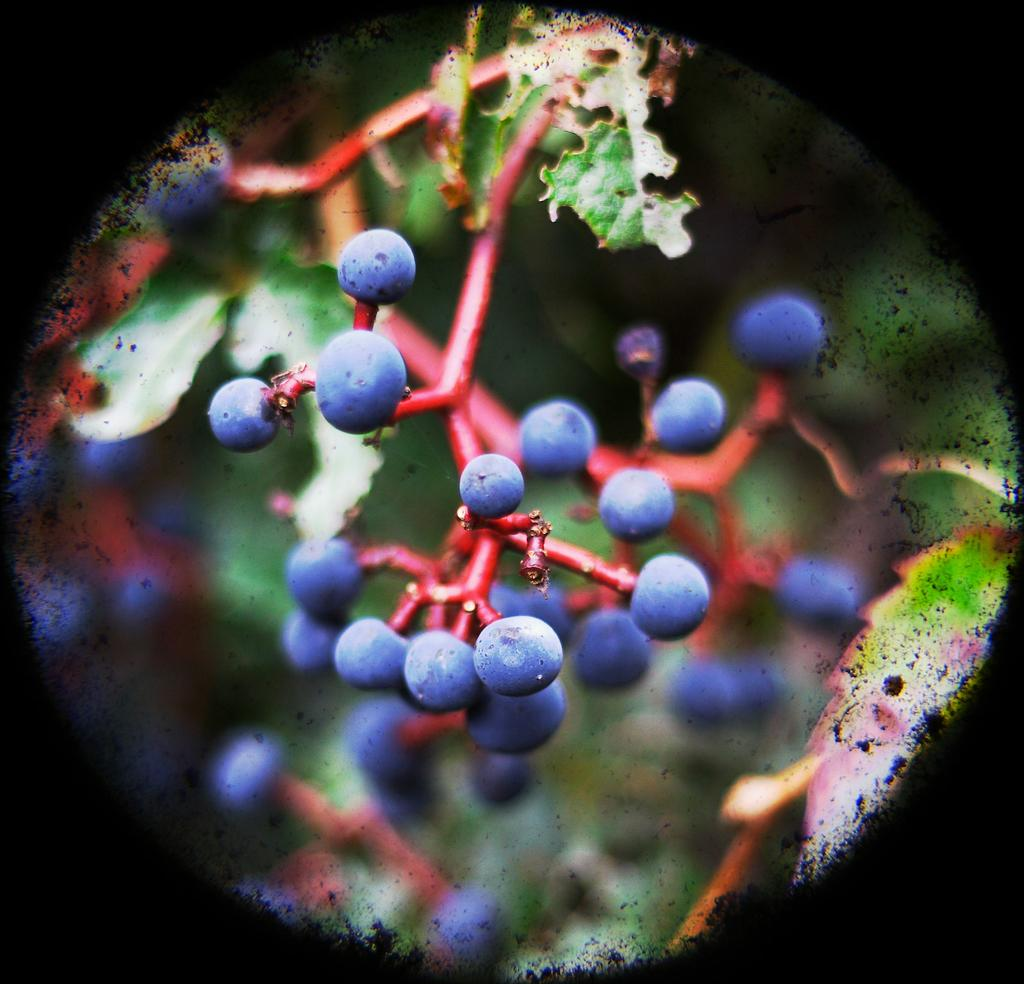What is the main subject of the image? The main subject of the image is a plant. What specific feature can be observed on the plant? The plant has berries. How is the image framed or presented? The image is framed with a circle. What type of butter is being used to decorate the plant in the image? There is no butter present in the image; it features a plant with berries. Can you tell me how many quinces are hanging from the plant in the image? There are no quinces present in the image; the plant has berries. 